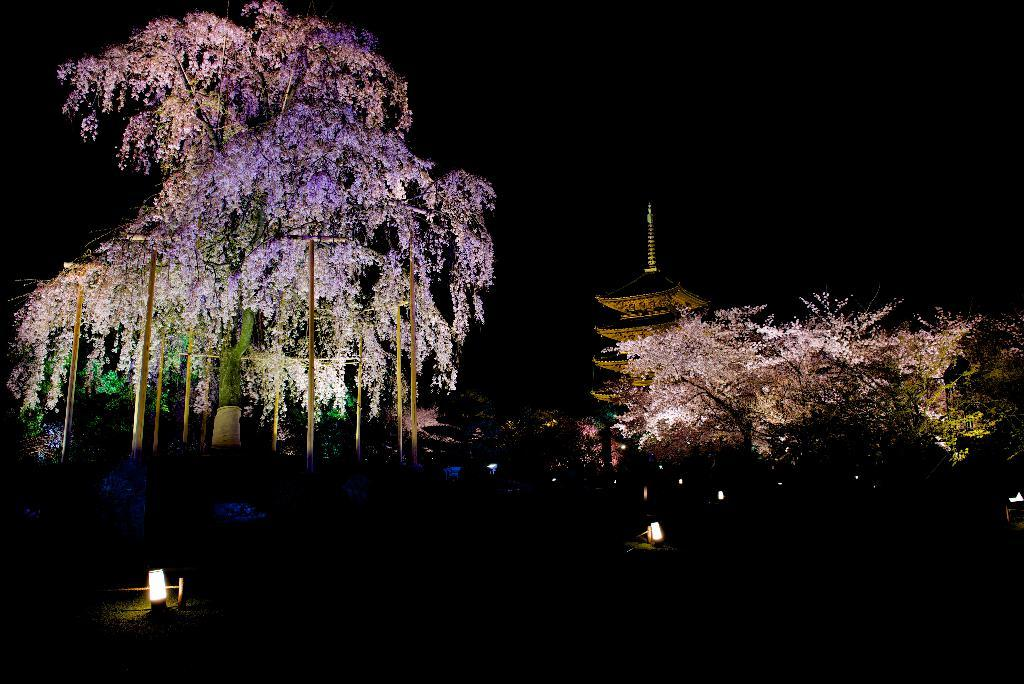What type of natural elements can be seen in the image? There are trees in the image. What man-made structures are present in the image? There are poles and a building in the image. What is visible on the ground in the image? There are lights on the ground in the image. What is the condition of the sky in the image? The sky is dark in the image. What statement was made by the committee in the image? There is no committee or statement present in the image. How does the end of the image look like? The image does not have an "end" as it is a two-dimensional representation. 